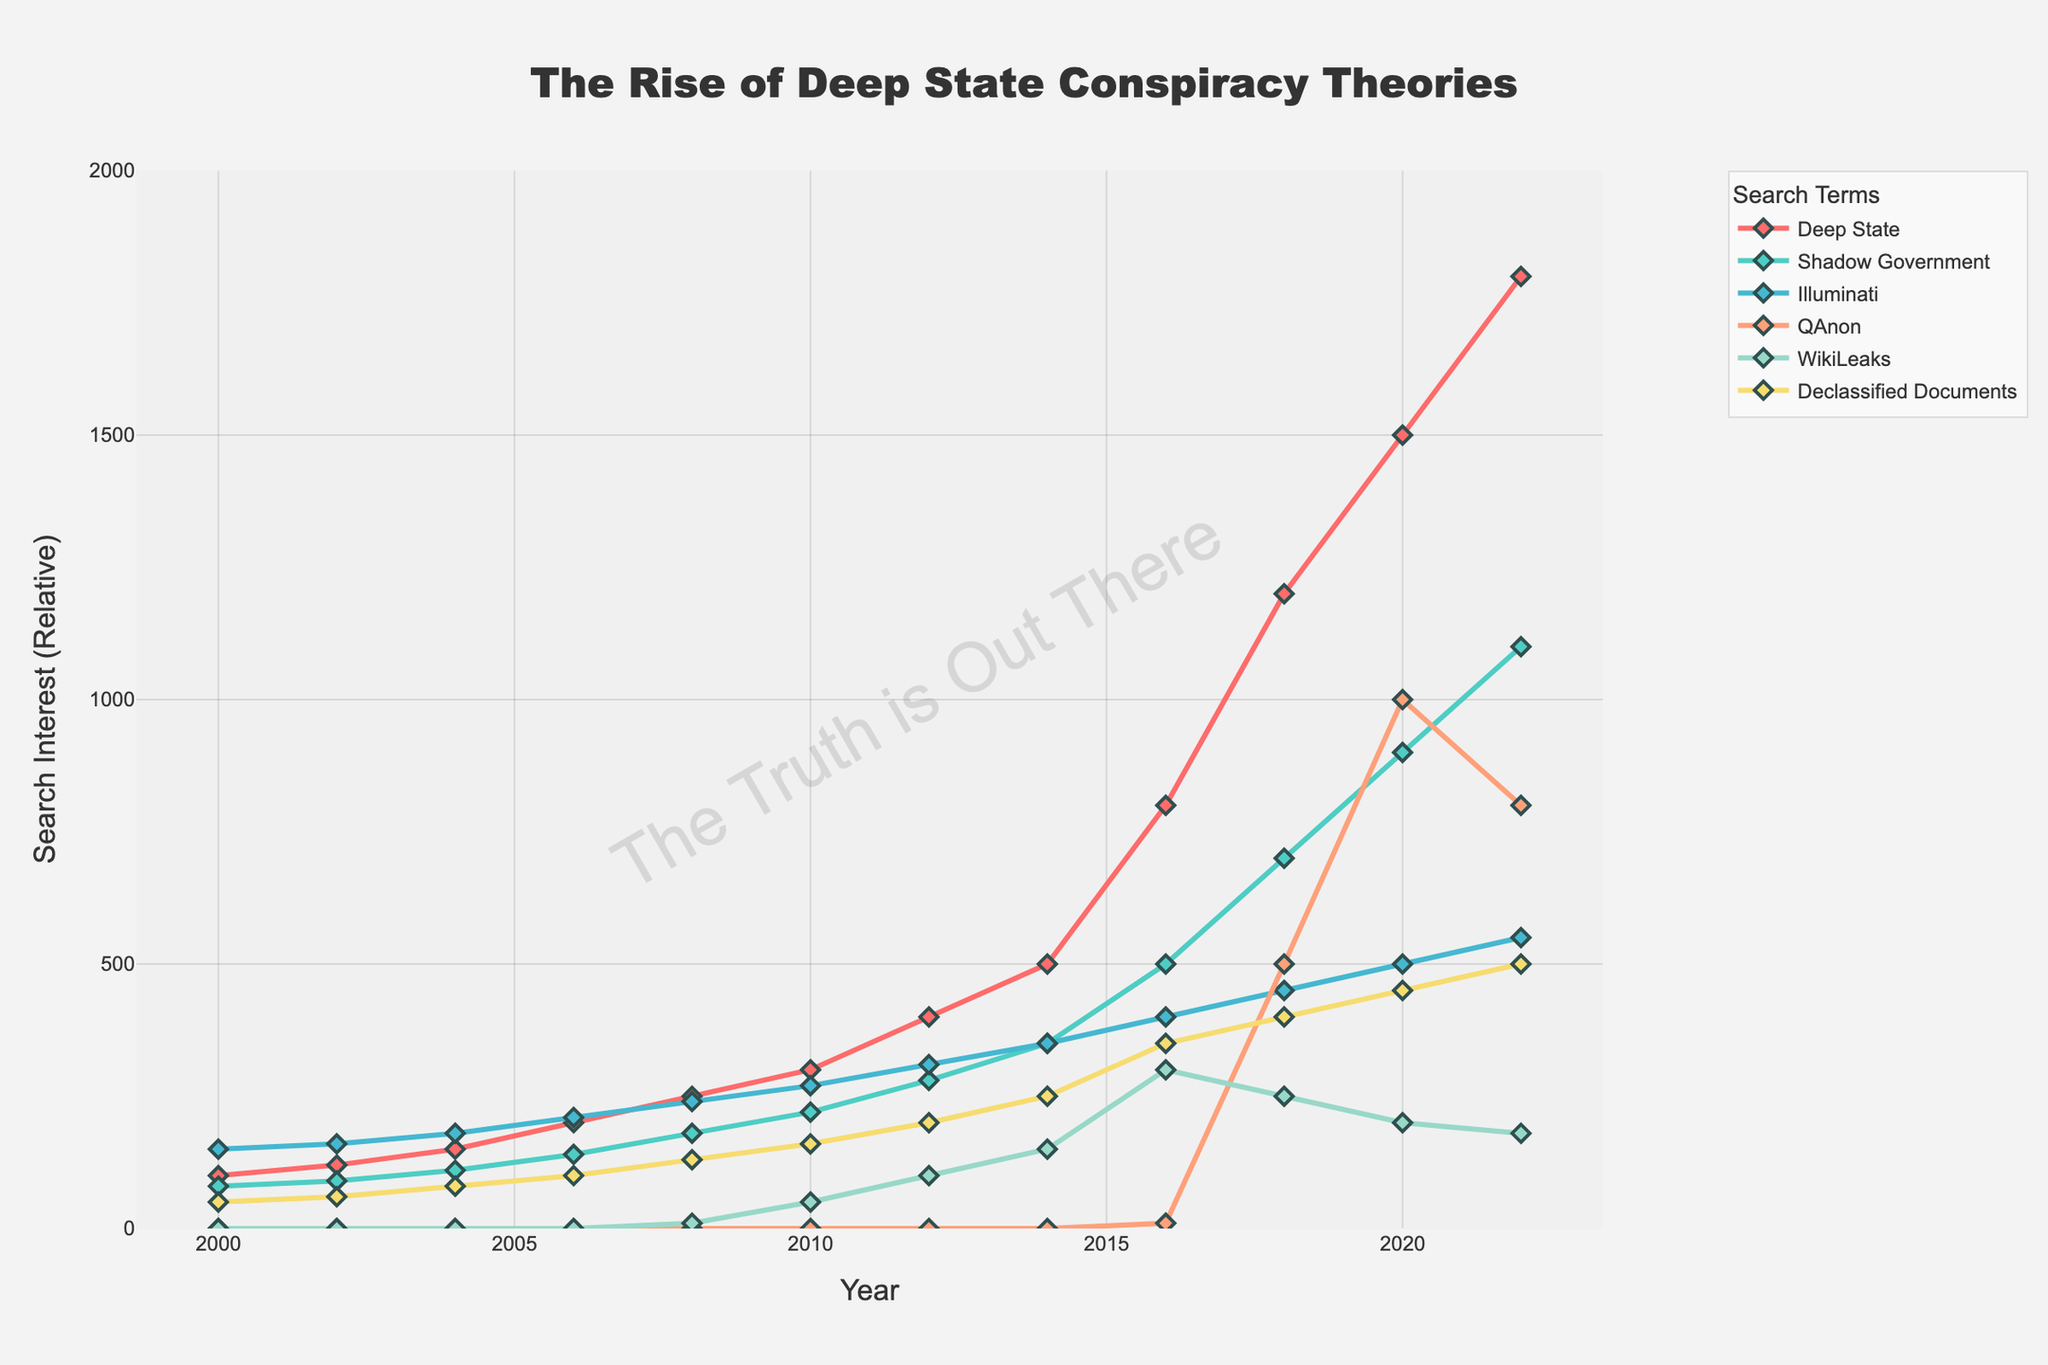What is the highest value for "Deep State" searches and in which year did it occur? The highest value for "Deep State" searches can be identified by looking for the tallest line segment for "Deep State". The peak value of "Deep State" searches is 1800 in the year 2022.
Answer: 1800 in 2022 How did the searches for "QAnon" change between 2016 and 2020? To determine the change in "QAnon" searches between 2016 and 2020, observe the values for those years. In 2016, the value is 10 and in 2020 it is 1000. The change is 1000 - 10 = 990.
Answer: Increased by 990 What is the sum of searches for "WikiLeaks" and "Declassified Documents" in 2018? Add the values for "WikiLeaks" and "Declassified Documents" in 2018: WikiLeaks (250) + Declassified Documents (400) = 650.
Answer: 650 Which search term had the smallest overall increase from 2000 to present? By observing the starting and ending values of each search term, "Shadow Government" has increased from 80 to 1100, "Illuminati" from 150 to 550, "QAnon" from 0 to 800, "WikiLeaks" from 0 to 180, and "Declassified Documents" from 50 to 500. "Illuminati" has the smallest increase from 150 to 550, which is +400.
Answer: Illuminati Which search term showed the most significant increase between 2008 and 2012? To determine this, compare the increases for each term over this period. "Deep State" increased from 250 to 400 (+150), "Shadow Government" from 180 to 280 (+100), "Illuminati" from 240 to 310 (+70), "QAnon" stayed at 0, "WikiLeaks" from 10 to 100 (+90), and "Declassified Documents" from 130 to 200 (+70). The largest increase is for "Deep State".
Answer: Deep State What is the average search interest for "Declassified Documents" over the years? Calculate the average by dividing the sum of values by the number of years listed. Sum = 50 + 60 + 80 + 100 + 130 + 160 + 200 + 250 + 350 + 400 + 450 + 500 = 2730. There are 12 years of data, so 2730 / 12 = 227.5.
Answer: 227.5 Which search term had the highest value in the year 2016? Look at the values for all search terms in 2016. "Deep State" is 800, while the others are all lower: "Shadow Government" 500, "Illuminati" 400, "QAnon" 10, "WikiLeaks" 300, "Declassified Documents" 350. "Deep State" had the highest value.
Answer: Deep State Compare the search interest for "Shadow Government" and "Illuminati" in 2014. Which was higher and by how much? In 2014, the search value for "Shadow Government" is 350 and for "Illuminati" is 350. Both had the same value, so there is no difference between them.
Answer: Same, 0 How did searches for "WikiLeaks" trend from 2010 to 2022? Trace the line for "WikiLeaks" over these years: 2010 (50), 2012 (100), 2014 (150), 2016 (300), 2018 (250), 2020 (200), 2022 (180). The trend shows an initial increase peaking at 300 in 2016, then a decrease to 180 by 2022.
Answer: Peaked in 2016, then decreased to 180 What is the difference in search interest between "Deep State" and "QAnon" in 2020? Look at the values in 2020: "Deep State" is 1500, and "QAnon" is 1000. The difference is 1500 - 1000 = 500.
Answer: 500 